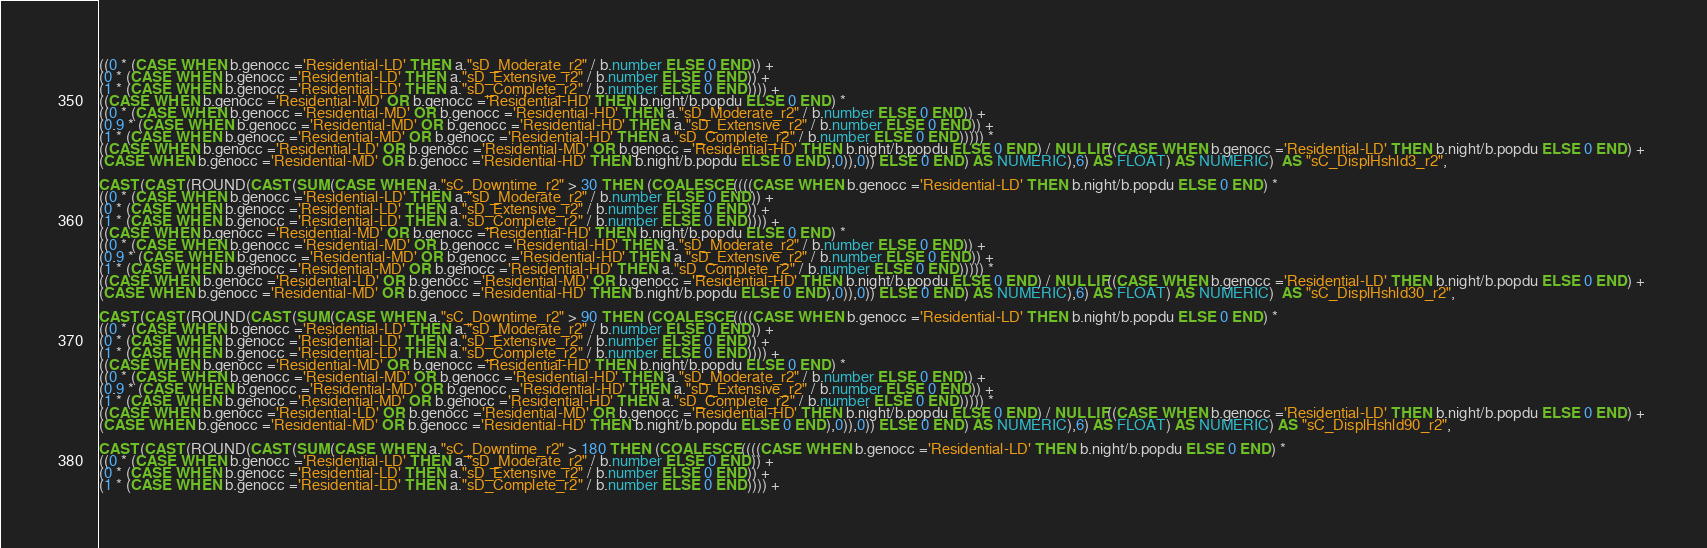Convert code to text. <code><loc_0><loc_0><loc_500><loc_500><_SQL_>((0 * (CASE WHEN b.genocc ='Residential-LD' THEN a."sD_Moderate_r2" / b.number ELSE 0 END)) + 
(0 * (CASE WHEN b.genocc ='Residential-LD' THEN a."sD_Extensive_r2" / b.number ELSE 0 END)) + 
(1 * (CASE WHEN b.genocc ='Residential-LD' THEN a."sD_Complete_r2" / b.number ELSE 0 END)))) + 
((CASE WHEN b.genocc ='Residential-MD' OR b.genocc ='Residential-HD' THEN b.night/b.popdu ELSE 0 END) *
((0 * (CASE WHEN b.genocc ='Residential-MD' OR b.genocc ='Residential-HD' THEN a."sD_Moderate_r2" / b.number ELSE 0 END)) + 
(0.9 * (CASE WHEN b.genocc ='Residential-MD' OR b.genocc ='Residential-HD' THEN a."sD_Extensive_r2" / b.number ELSE 0 END)) + 
(1 * (CASE WHEN b.genocc ='Residential-MD' OR b.genocc ='Residential-HD' THEN a."sD_Complete_r2" / b.number ELSE 0 END))))) * 
((CASE WHEN b.genocc ='Residential-LD' OR b.genocc ='Residential-MD' OR b.genocc ='Residential-HD' THEN b.night/b.popdu ELSE 0 END) / NULLIF((CASE WHEN b.genocc ='Residential-LD' THEN b.night/b.popdu ELSE 0 END) + 
(CASE WHEN b.genocc ='Residential-MD' OR b.genocc ='Residential-HD' THEN b.night/b.popdu ELSE 0 END),0)),0)) ELSE 0 END) AS NUMERIC),6) AS FLOAT) AS NUMERIC)  AS "sC_DisplHshld3_r2",

CAST(CAST(ROUND(CAST(SUM(CASE WHEN a."sC_Downtime_r2" > 30 THEN (COALESCE((((CASE WHEN b.genocc ='Residential-LD' THEN b.night/b.popdu ELSE 0 END) * 
((0 * (CASE WHEN b.genocc ='Residential-LD' THEN a."sD_Moderate_r2" / b.number ELSE 0 END)) + 
(0 * (CASE WHEN b.genocc ='Residential-LD' THEN a."sD_Extensive_r2" / b.number ELSE 0 END)) + 
(1 * (CASE WHEN b.genocc ='Residential-LD' THEN a."sD_Complete_r2" / b.number ELSE 0 END)))) + 
((CASE WHEN b.genocc ='Residential-MD' OR b.genocc ='Residential-HD' THEN b.night/b.popdu ELSE 0 END) *
((0 * (CASE WHEN b.genocc ='Residential-MD' OR b.genocc ='Residential-HD' THEN a."sD_Moderate_r2" / b.number ELSE 0 END)) + 
(0.9 * (CASE WHEN b.genocc ='Residential-MD' OR b.genocc ='Residential-HD' THEN a."sD_Extensive_r2" / b.number ELSE 0 END)) + 
(1 * (CASE WHEN b.genocc ='Residential-MD' OR b.genocc ='Residential-HD' THEN a."sD_Complete_r2" / b.number ELSE 0 END))))) * 
((CASE WHEN b.genocc ='Residential-LD' OR b.genocc ='Residential-MD' OR b.genocc ='Residential-HD' THEN b.night/b.popdu ELSE 0 END) / NULLIF((CASE WHEN b.genocc ='Residential-LD' THEN b.night/b.popdu ELSE 0 END) + 
(CASE WHEN b.genocc ='Residential-MD' OR b.genocc ='Residential-HD' THEN b.night/b.popdu ELSE 0 END),0)),0)) ELSE 0 END) AS NUMERIC),6) AS FLOAT) AS NUMERIC)  AS "sC_DisplHshld30_r2",

CAST(CAST(ROUND(CAST(SUM(CASE WHEN a."sC_Downtime_r2" > 90 THEN (COALESCE((((CASE WHEN b.genocc ='Residential-LD' THEN b.night/b.popdu ELSE 0 END) * 
((0 * (CASE WHEN b.genocc ='Residential-LD' THEN a."sD_Moderate_r2" / b.number ELSE 0 END)) + 
(0 * (CASE WHEN b.genocc ='Residential-LD' THEN a."sD_Extensive_r2" / b.number ELSE 0 END)) + 
(1 * (CASE WHEN b.genocc ='Residential-LD' THEN a."sD_Complete_r2" / b.number ELSE 0 END)))) + 
((CASE WHEN b.genocc ='Residential-MD' OR b.genocc ='Residential-HD' THEN b.night/b.popdu ELSE 0 END) *
((0 * (CASE WHEN b.genocc ='Residential-MD' OR b.genocc ='Residential-HD' THEN a."sD_Moderate_r2" / b.number ELSE 0 END)) + 
(0.9 * (CASE WHEN b.genocc ='Residential-MD' OR b.genocc ='Residential-HD' THEN a."sD_Extensive_r2" / b.number ELSE 0 END)) + 
(1 * (CASE WHEN b.genocc ='Residential-MD' OR b.genocc ='Residential-HD' THEN a."sD_Complete_r2" / b.number ELSE 0 END))))) * 
((CASE WHEN b.genocc ='Residential-LD' OR b.genocc ='Residential-MD' OR b.genocc ='Residential-HD' THEN b.night/b.popdu ELSE 0 END) / NULLIF((CASE WHEN b.genocc ='Residential-LD' THEN b.night/b.popdu ELSE 0 END) + 
(CASE WHEN b.genocc ='Residential-MD' OR b.genocc ='Residential-HD' THEN b.night/b.popdu ELSE 0 END),0)),0)) ELSE 0 END) AS NUMERIC),6) AS FLOAT) AS NUMERIC) AS "sC_DisplHshld90_r2",

CAST(CAST(ROUND(CAST(SUM(CASE WHEN a."sC_Downtime_r2" > 180 THEN (COALESCE((((CASE WHEN b.genocc ='Residential-LD' THEN b.night/b.popdu ELSE 0 END) * 
((0 * (CASE WHEN b.genocc ='Residential-LD' THEN a."sD_Moderate_r2" / b.number ELSE 0 END)) + 
(0 * (CASE WHEN b.genocc ='Residential-LD' THEN a."sD_Extensive_r2" / b.number ELSE 0 END)) + 
(1 * (CASE WHEN b.genocc ='Residential-LD' THEN a."sD_Complete_r2" / b.number ELSE 0 END)))) + </code> 